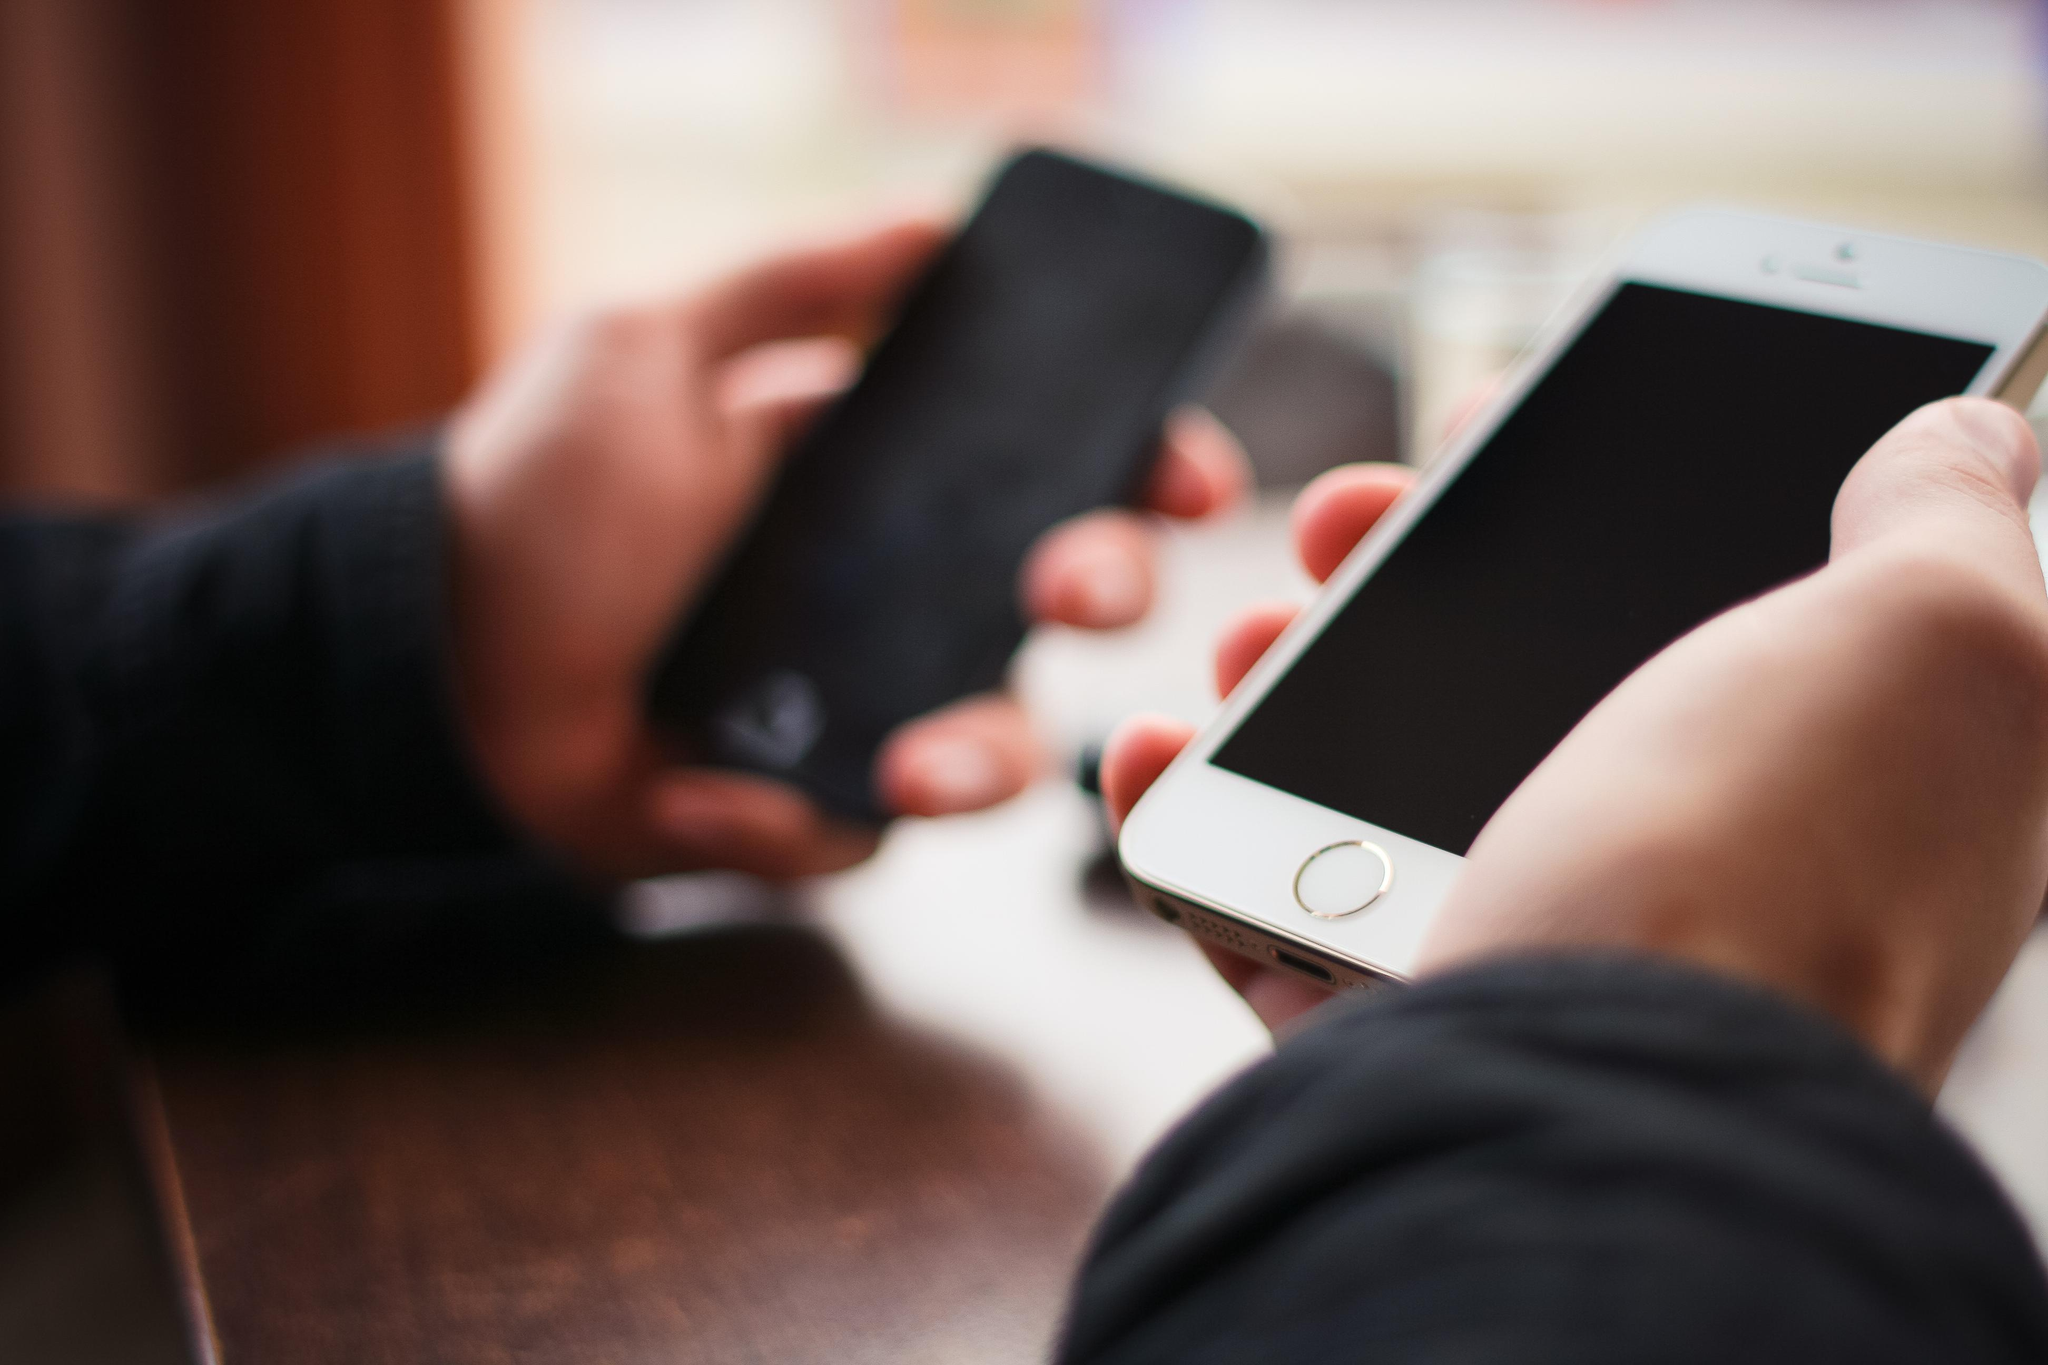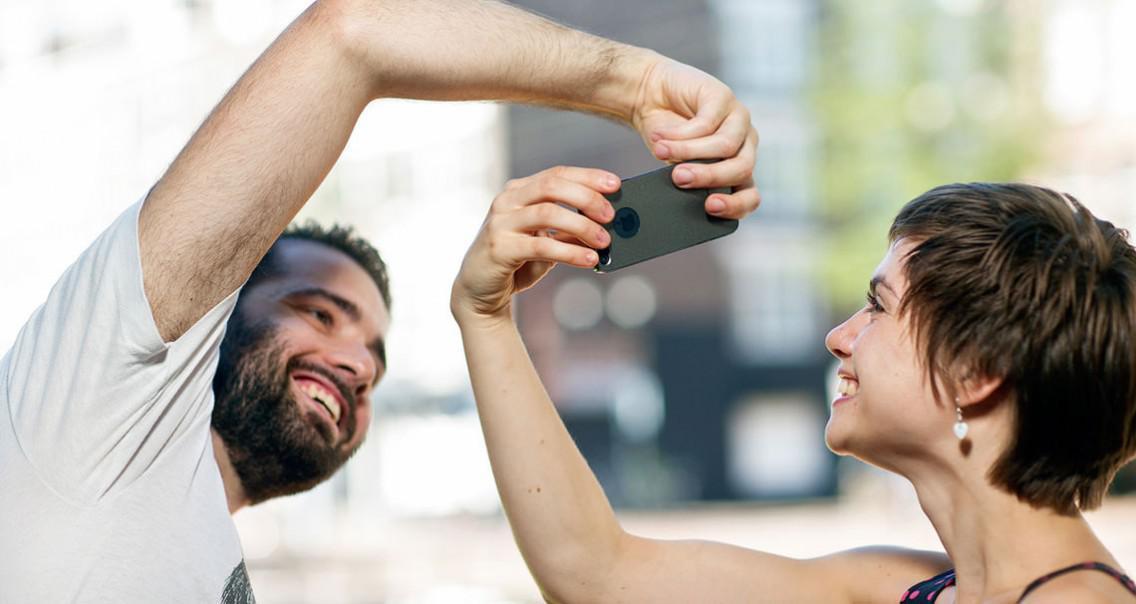The first image is the image on the left, the second image is the image on the right. Examine the images to the left and right. Is the description "Exactly one phones is in contact with a single hand." accurate? Answer yes or no. No. The first image is the image on the left, the second image is the image on the right. Considering the images on both sides, is "A single hand is holding a phone upright and head-on in one image, and the other image includes hands reaching in from opposite sides." valid? Answer yes or no. No. 